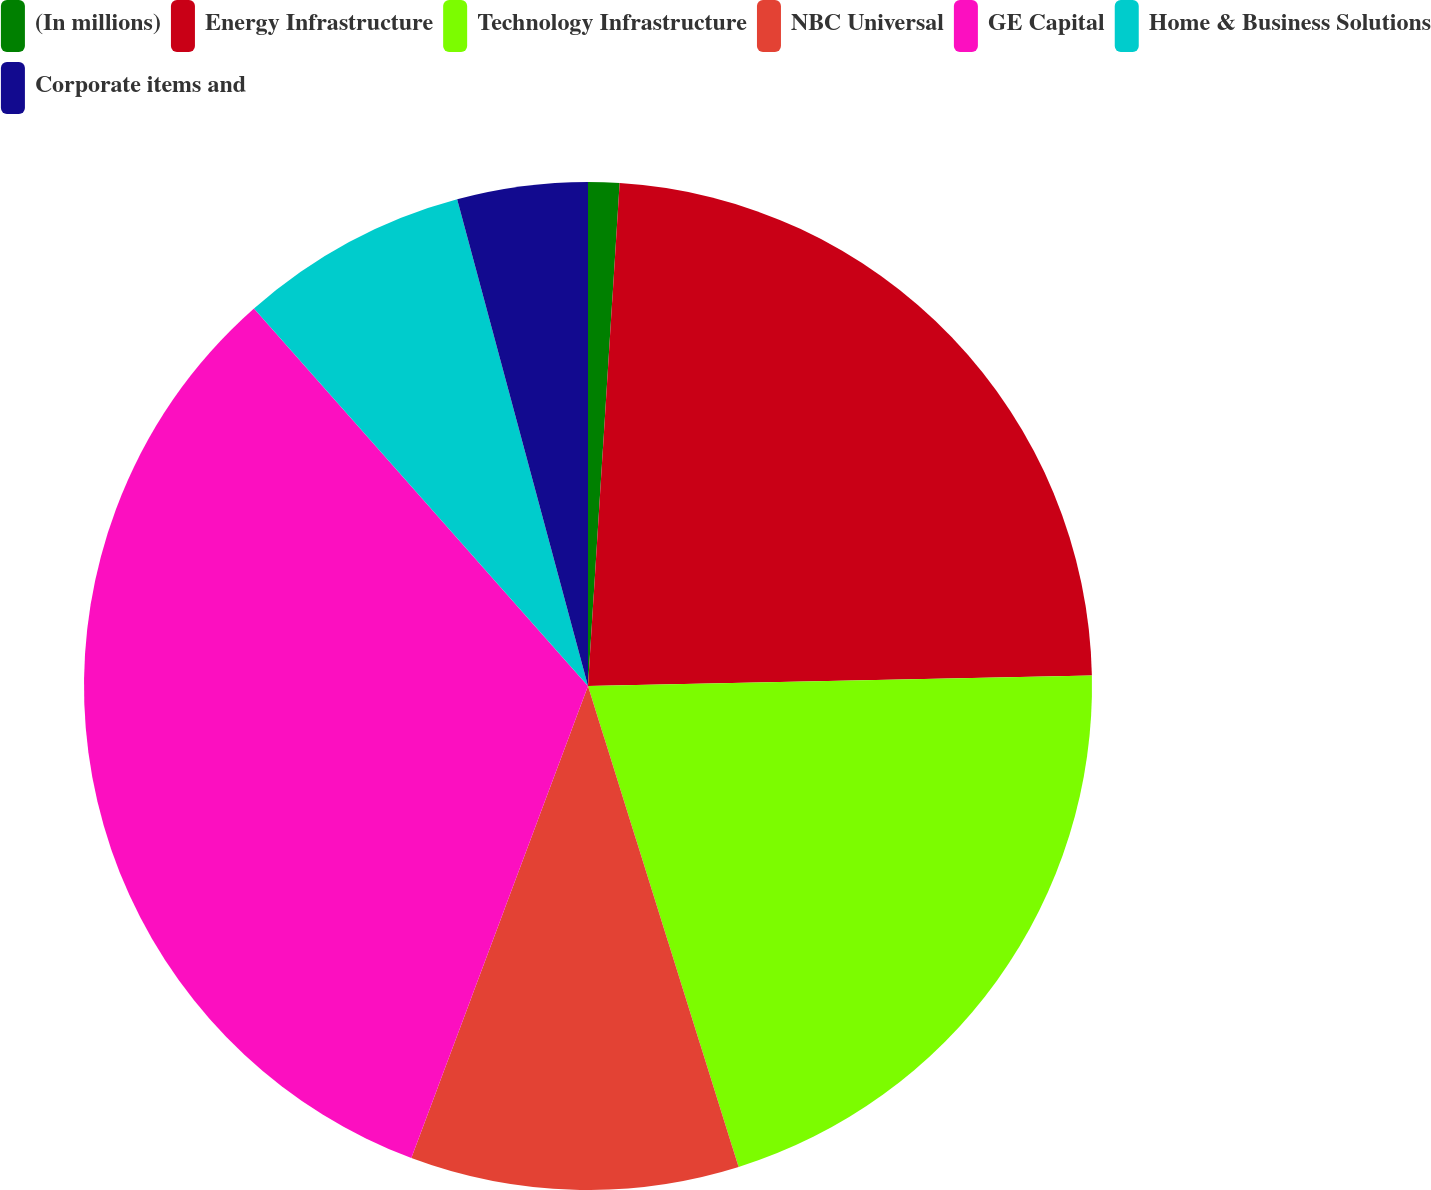Convert chart to OTSL. <chart><loc_0><loc_0><loc_500><loc_500><pie_chart><fcel>(In millions)<fcel>Energy Infrastructure<fcel>Technology Infrastructure<fcel>NBC Universal<fcel>GE Capital<fcel>Home & Business Solutions<fcel>Corporate items and<nl><fcel>1.0%<fcel>23.67%<fcel>20.5%<fcel>10.53%<fcel>32.77%<fcel>7.35%<fcel>4.18%<nl></chart> 